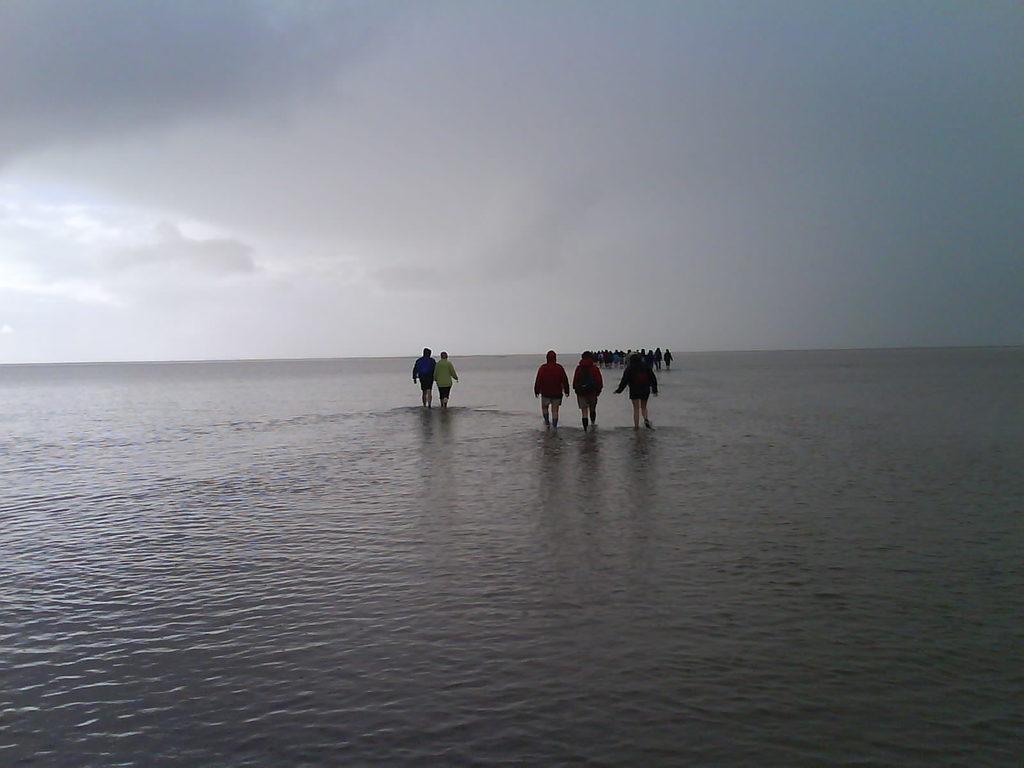What is present in the image? There is water in the image. What are the people in the image doing? The people are standing in the water. What can be seen in the background of the image? The sky is visible in the background of the image. Where can the ants be seen in the image? There are no ants present in the image. 